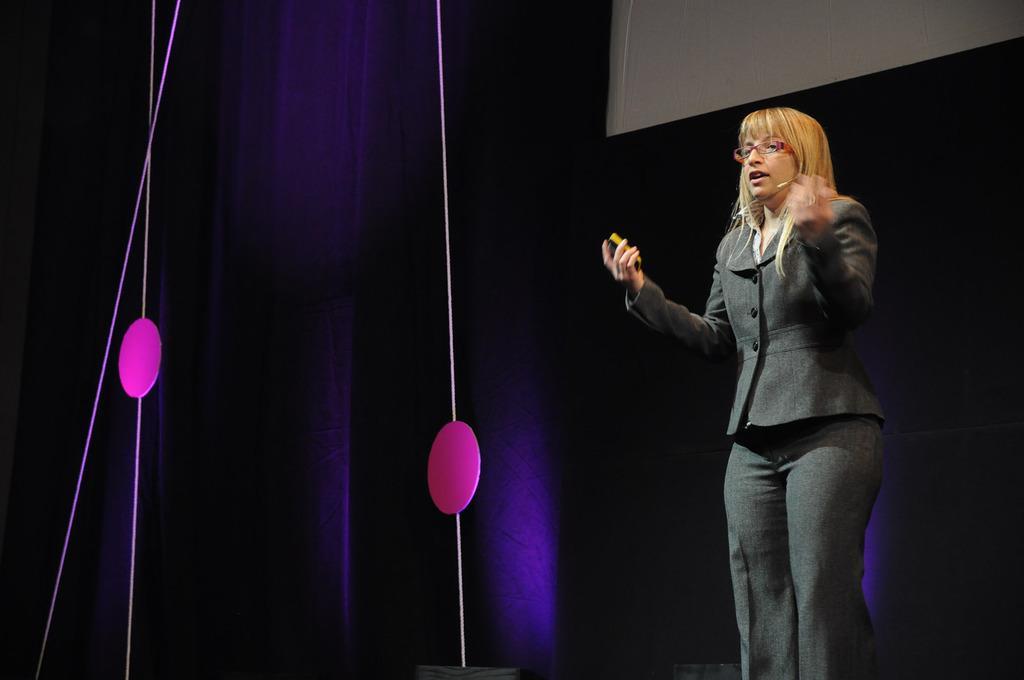How would you summarize this image in a sentence or two? On the right side of the image there is a lady standing and she kept spectacles and she is having mic. And she is holding an object in her hand. Behind her at the top of the image there is a screen. And also there are decorative items and lights in the background. 